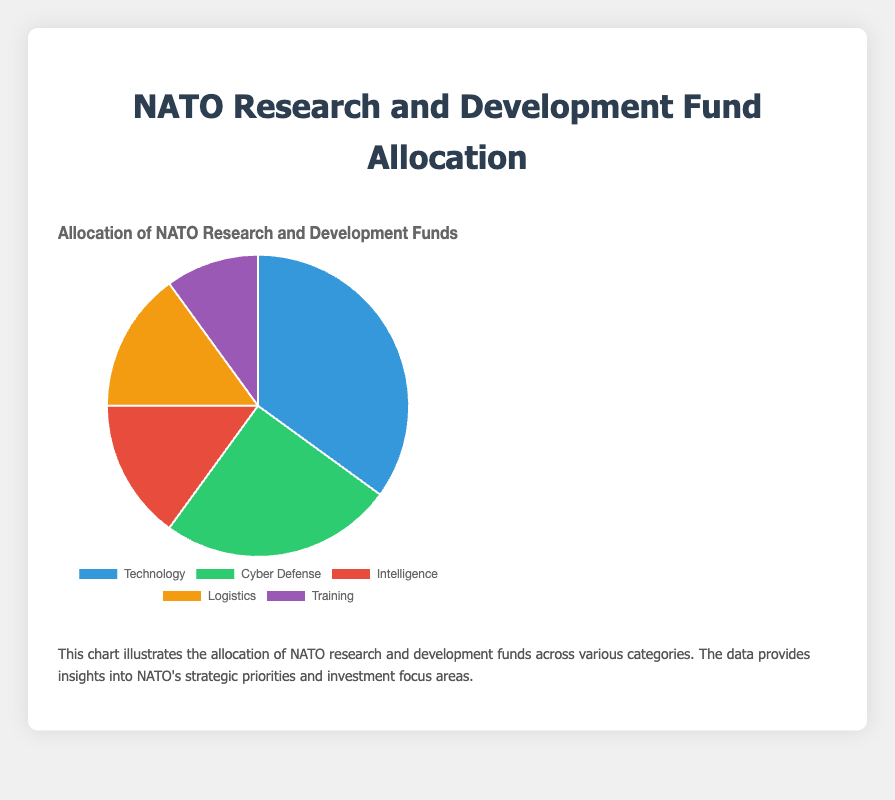What category has the largest allocation of NATO research and development funds? By looking at the pie chart, the segment with the largest area, which indicates the highest percentage allocation, is "Technology" with 35%.
Answer: Technology How much more funding does Technology receive compared to Training? From the chart, Technology is allocated 35%, and Training is allocated 10%. To find the difference, subtract Training’s percentage from Technology’s percentage (35% - 10% = 25%).
Answer: 25% What is the total allocation percentage for Intelligence and Logistics combined? The chart shows that Intelligence is allocated 15% and Logistics is also allocated 15%. The combined allocation is the sum of these two percentages (15% + 15% = 30%).
Answer: 30% Which category has the smallest allocation of NATO research and development funds? By observing the pie chart, the segment with the smallest area, indicating the lowest percentage allocation, is "Training" with 10%.
Answer: Training How does the allocation for Cyber Defense compare to Intelligence? According to the chart, Cyber Defense is allocated 25%, while Intelligence is allocated 15%. Cyber Defense has a higher allocation by (25% - 15% = 10%).
Answer: Cyber Defense has 10% more Which two categories have the same percentage allocation, and what is their combined total allocation? By examining the chart, both Intelligence and Logistics are allocated 15% each. Their combined total allocation is the sum of these two percentages (15% + 15% = 30%).
Answer: Intelligence and Logistics; 30% What percentage of the total allocation goes to non-Technology categories? Technology receives 35%, meaning non-Technology categories receive the remainder. Subtract Technology’s allocation from 100% (100% - 35% = 65%).
Answer: 65% If the total NATO research and development budget is $100 million, how much funding (in dollars) is allocated to Cyber Defense? Cyber Defense is allocated 25% of the total budget. If the total budget is $100 million, calculate the funding by multiplying 25% by $100 million (0.25 * 100 million = $25 million).
Answer: $25 million 